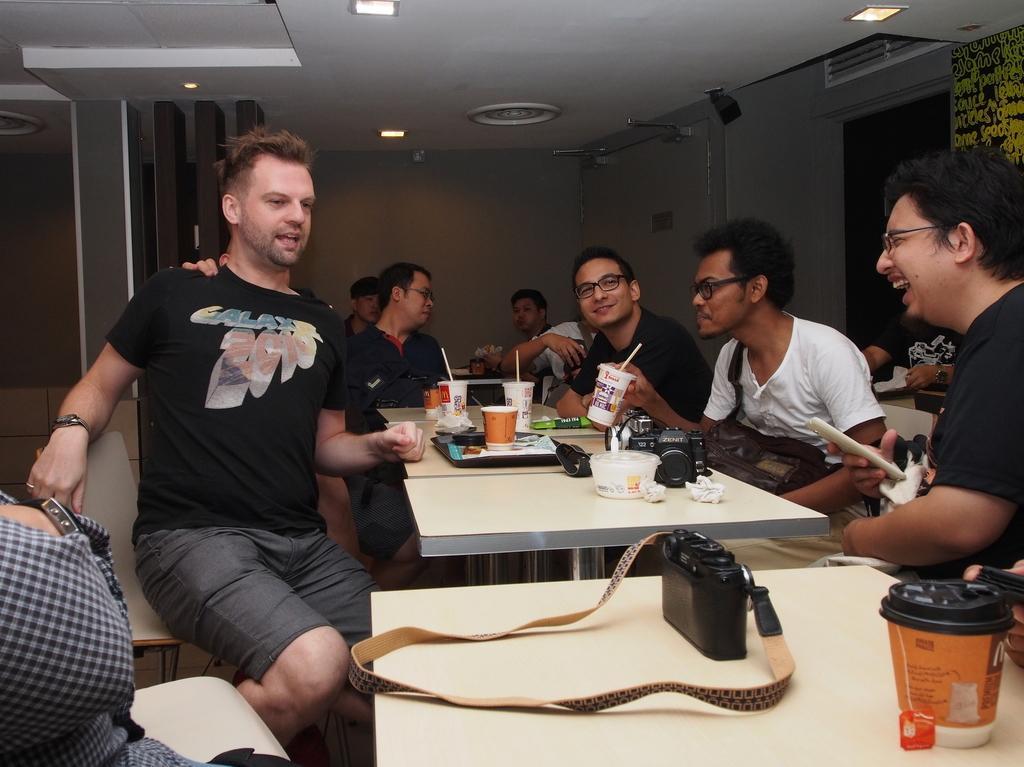Can you describe this image briefly? In this picture, there are group of people sitting on chair facing each other. In the middle of the image, there is a table on which tray, paper glasses, straw, box and camera is kept. The roof top is white in color, on which light is fixed. The background wall is ash in color. In the right top we can see a door, which is brown in color. At the bottom of the image, there is another table on which camera holder is kept and bottle is kept. 